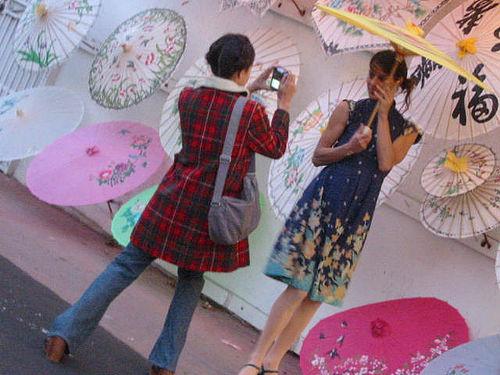Can you see fruit?
Quick response, please. No. Is the person on the right holding a spoon?
Keep it brief. No. What character is on the umbrella?
Short answer required. Chinese. What season is it?
Quick response, please. Spring. What color is the cloth being used?
Quick response, please. Blue. What item is in the pouch?
Give a very brief answer. Wallet. What color is the wall?
Keep it brief. White. Are there items here that look like knitting needles, yet aren't?
Answer briefly. No. How many umbrellas are pink?
Answer briefly. 2. What are the objects hanging from the wall?
Short answer required. Umbrellas. Does the person appear to be young?
Answer briefly. Yes. What is the main color on the umbrella?
Write a very short answer. Pink. 